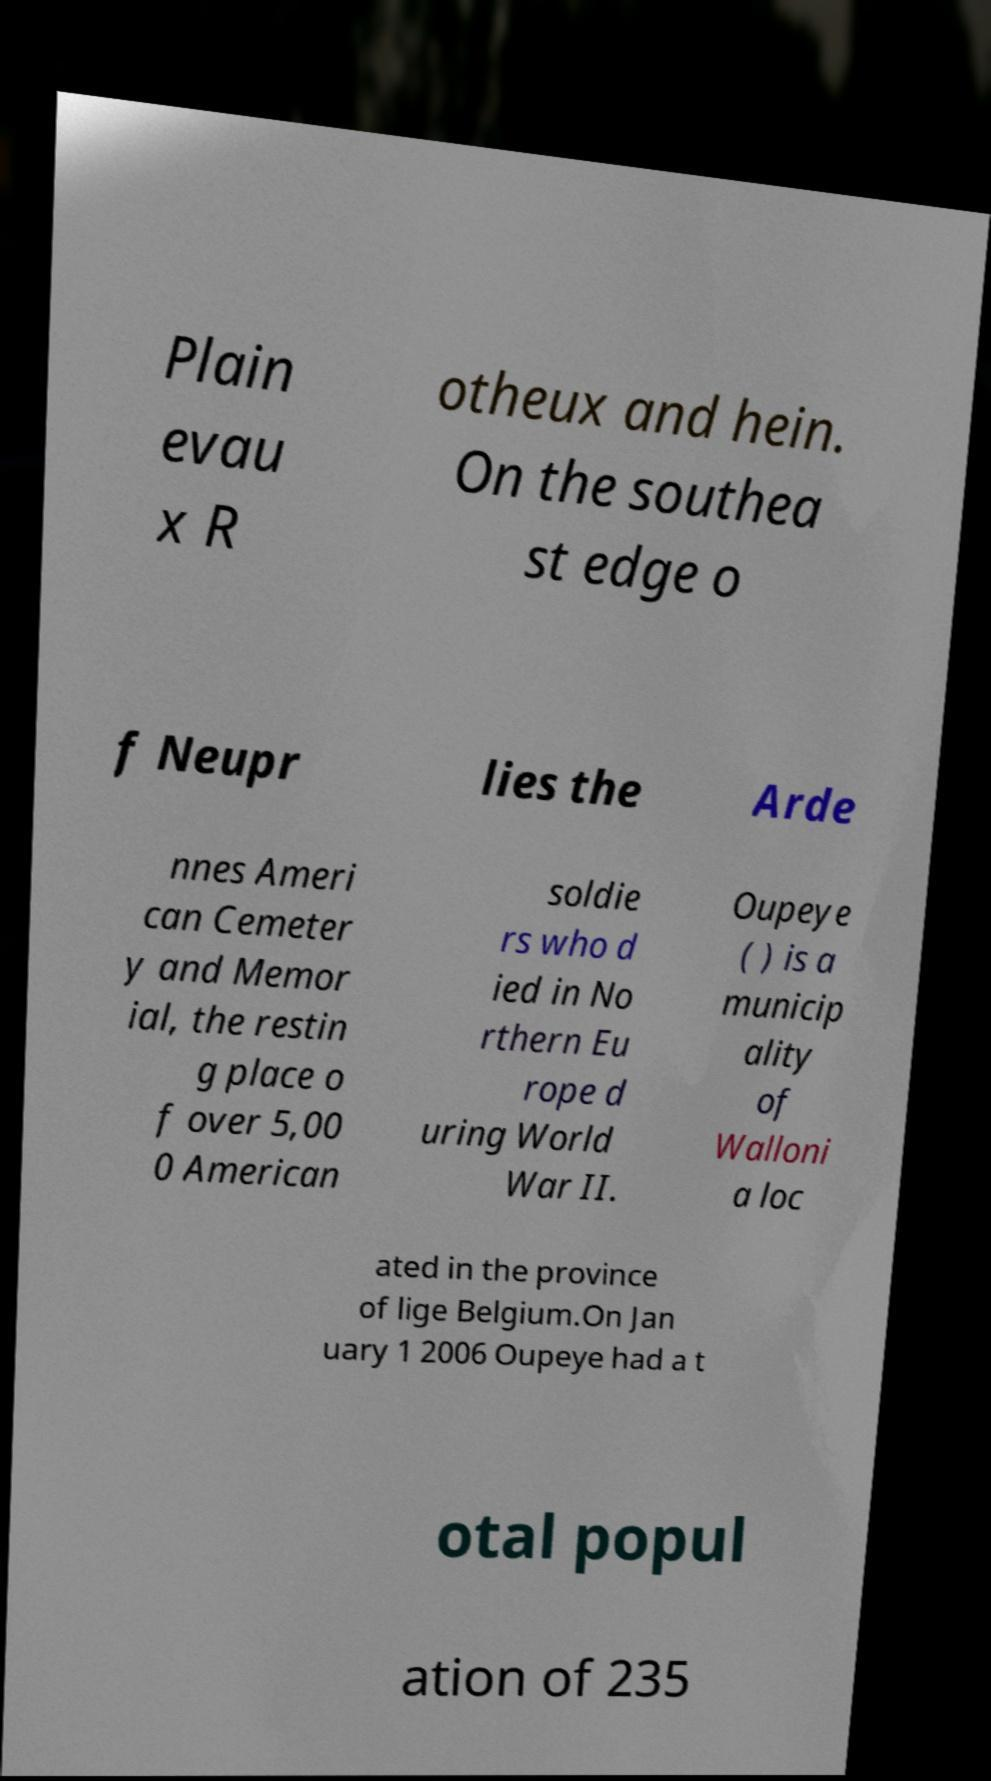What messages or text are displayed in this image? I need them in a readable, typed format. Plain evau x R otheux and hein. On the southea st edge o f Neupr lies the Arde nnes Ameri can Cemeter y and Memor ial, the restin g place o f over 5,00 0 American soldie rs who d ied in No rthern Eu rope d uring World War II. Oupeye ( ) is a municip ality of Walloni a loc ated in the province of lige Belgium.On Jan uary 1 2006 Oupeye had a t otal popul ation of 235 